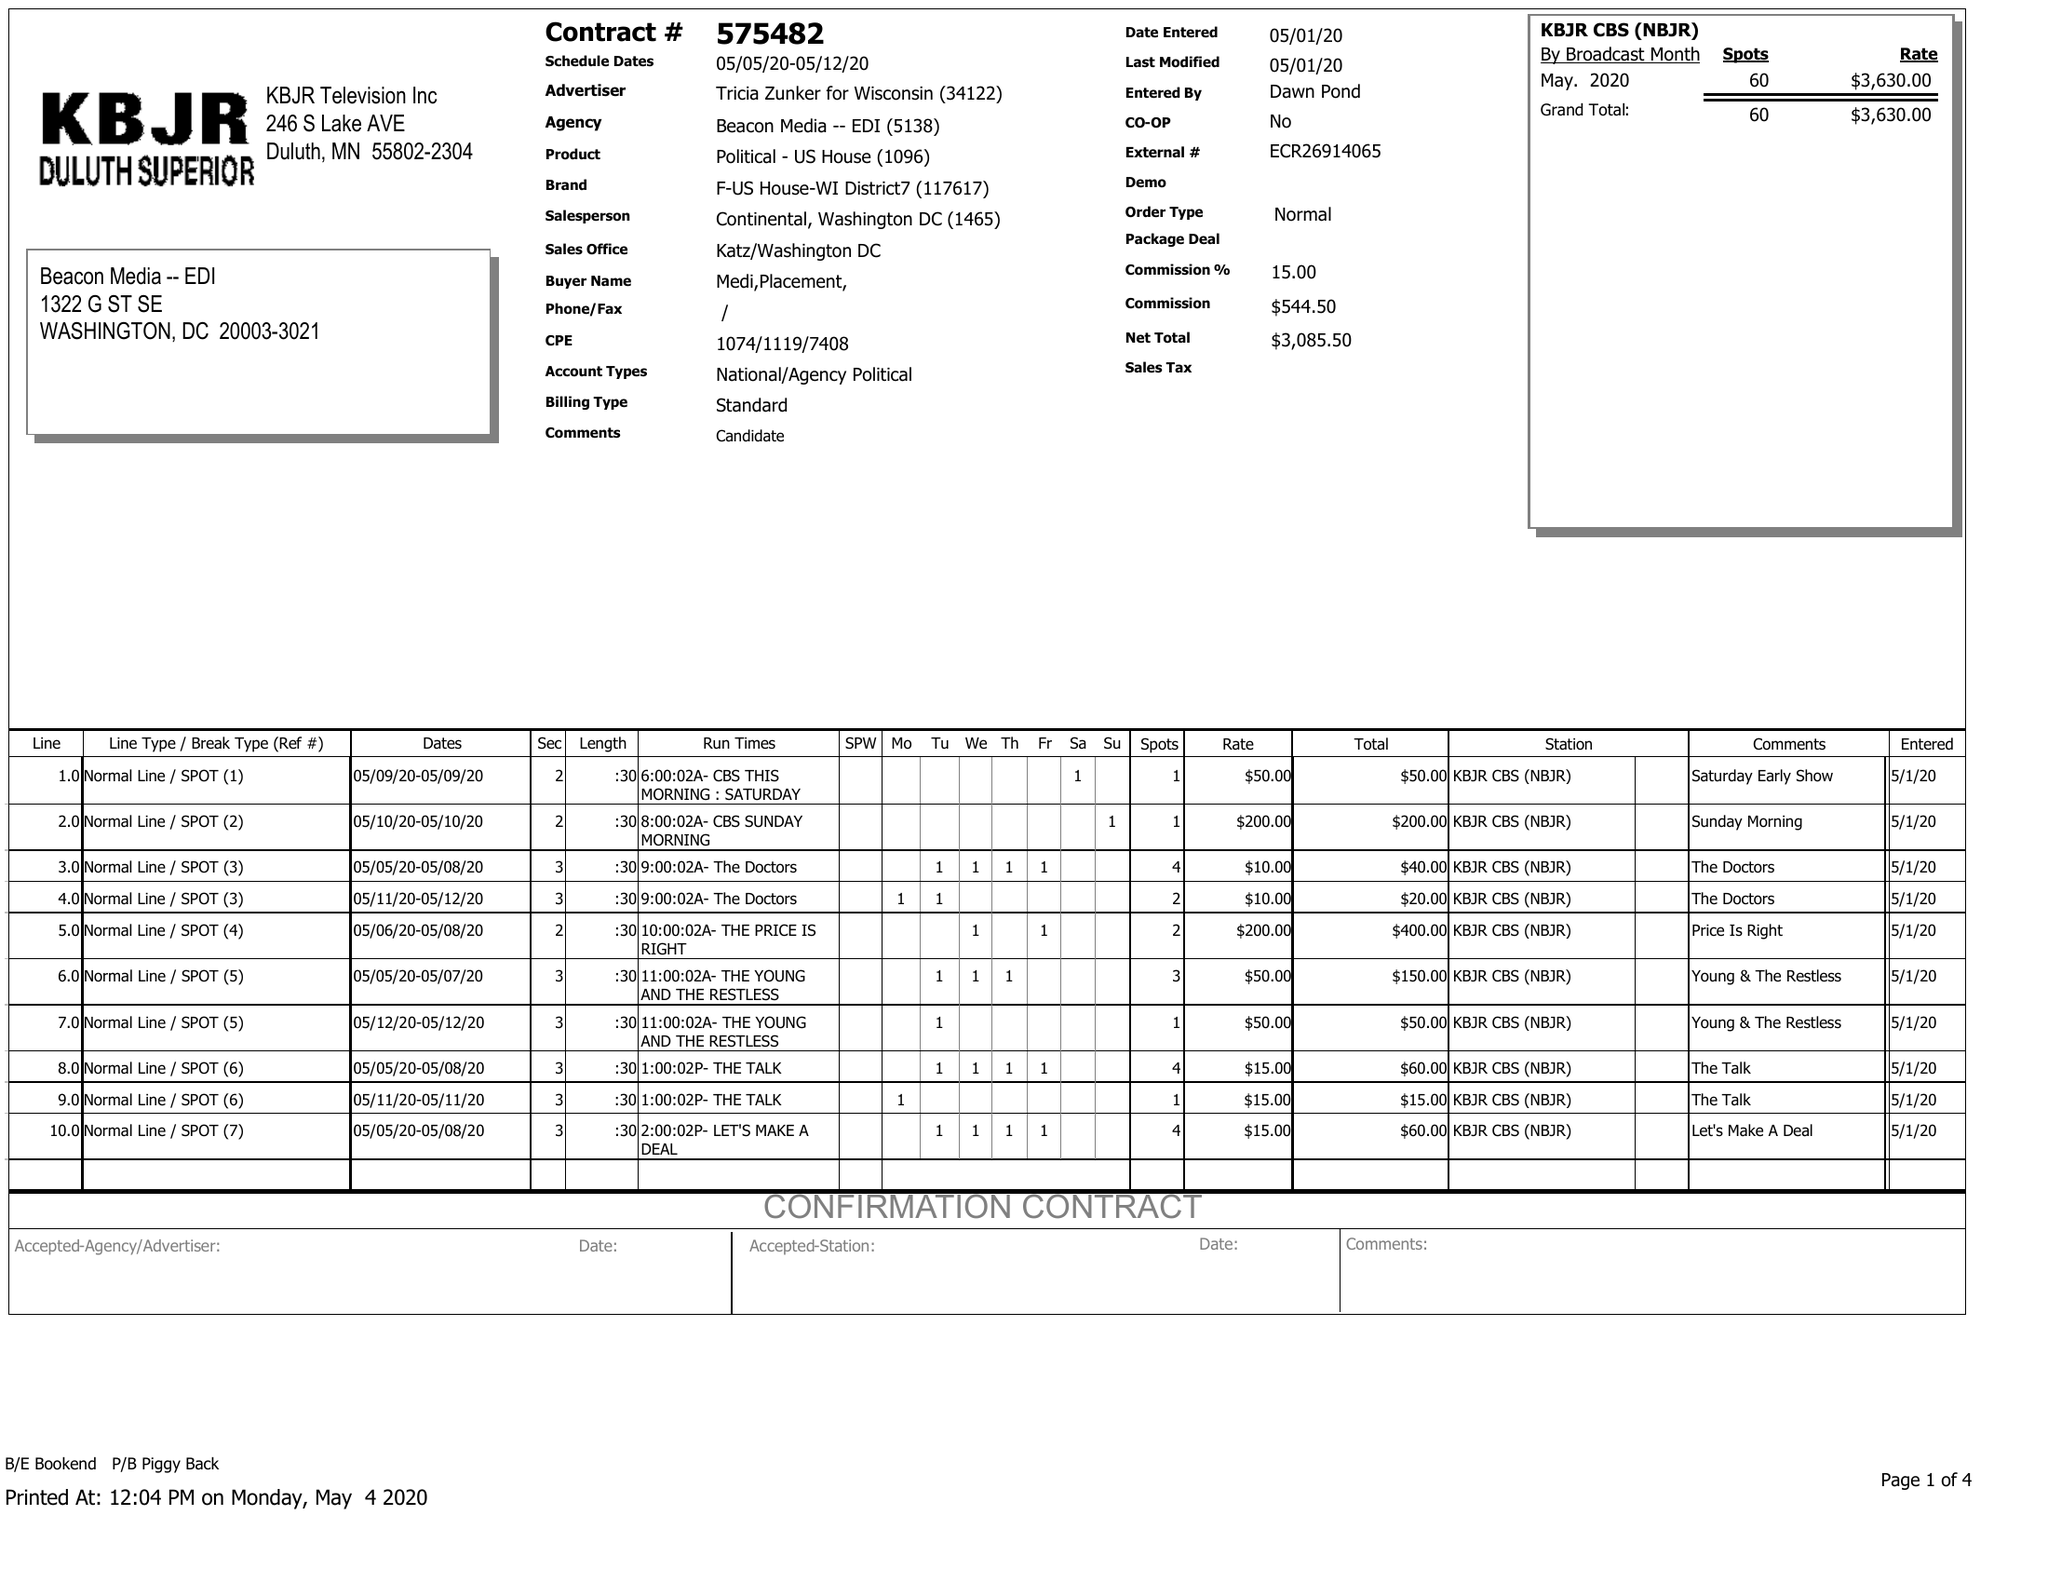What is the value for the gross_amount?
Answer the question using a single word or phrase. 3630.00 